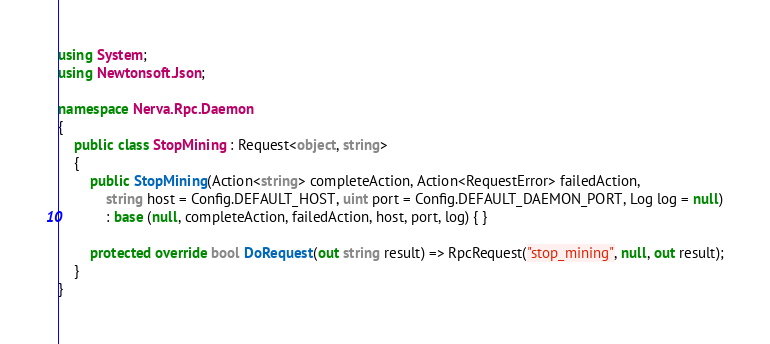<code> <loc_0><loc_0><loc_500><loc_500><_C#_>using System;
using Newtonsoft.Json;

namespace Nerva.Rpc.Daemon
{
    public class StopMining : Request<object, string>
    {
        public StopMining(Action<string> completeAction, Action<RequestError> failedAction, 
            string host = Config.DEFAULT_HOST, uint port = Config.DEFAULT_DAEMON_PORT, Log log = null)
            : base (null, completeAction, failedAction, host, port, log) { }

        protected override bool DoRequest(out string result) => RpcRequest("stop_mining", null, out result);
    }
}</code> 